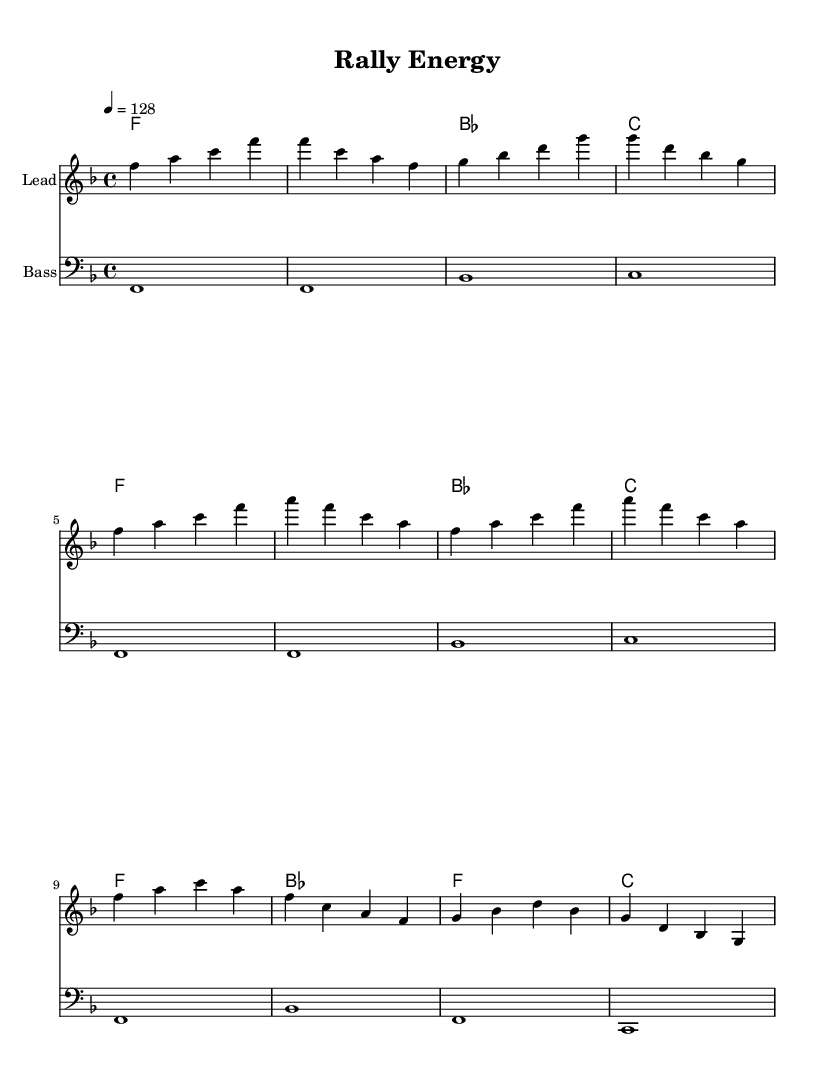What is the key signature of this music? The key signature is F major, which has one flat (B flat). This is indicated at the beginning of the score.
Answer: F major What is the time signature of this music? The time signature is 4/4, which is shown at the beginning of the score. It means there are four beats per measure.
Answer: 4/4 What is the tempo marking in beats per minute? The tempo is marked at 128 beats per minute, indicated by the tempo directive at the beginning.
Answer: 128 How many measures are in the melody section? The melody includes a total of 8 measures as analyzed in the provided music, including the intro, verse, and chorus.
Answer: 8 measures What are the first three chords used in the intro? The first three chords in the intro are F, F, and B flat, as shown in the harmonies section.
Answer: F, F, B flat What is the bass note for the first measure? The bass note for the first measure is F, which can be found in the bass part at the beginning.
Answer: F How does the chorus's harmonic structure change compared to the verse? In the chorus, the harmonic structure includes a B flat chord at the beginning, while the verse only has F and B flat. This indicates a slight variation to enhance the chorus's energy compared to the verse.
Answer: B flat 